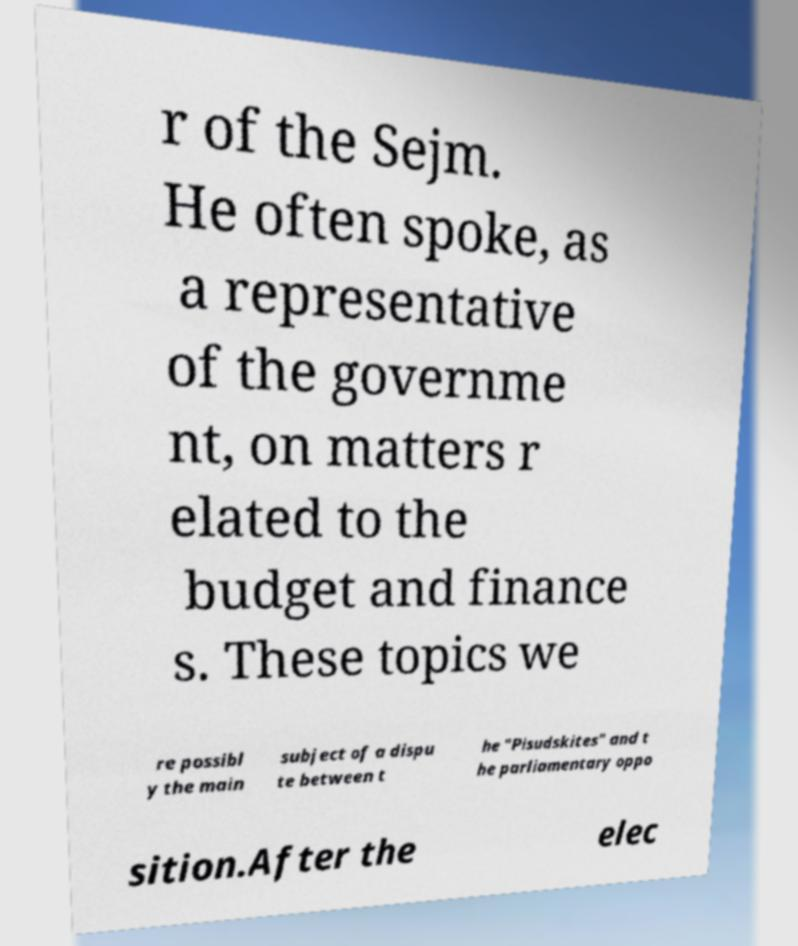What messages or text are displayed in this image? I need them in a readable, typed format. r of the Sejm. He often spoke, as a representative of the governme nt, on matters r elated to the budget and finance s. These topics we re possibl y the main subject of a dispu te between t he "Pisudskites" and t he parliamentary oppo sition.After the elec 